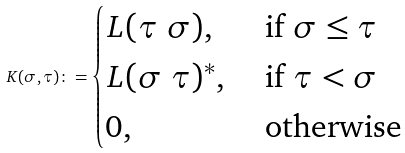Convert formula to latex. <formula><loc_0><loc_0><loc_500><loc_500>K ( \sigma , \tau ) \colon = \begin{cases} L ( \tau \ \sigma ) , & \text { if } \sigma \leq \tau \\ L ( \sigma \ \tau ) ^ { * } , & \text { if } \tau < \sigma \\ 0 , & \text { otherwise } \end{cases}</formula> 